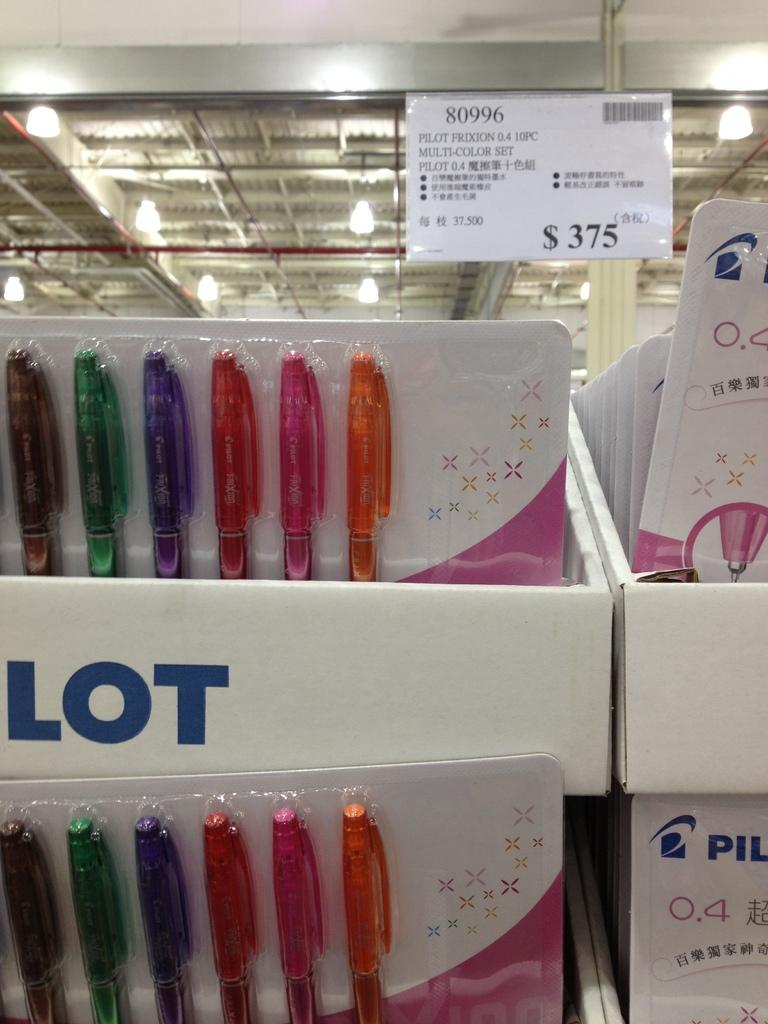How many pen packets are visible in the image? There are two pen packets in the image. What color are the boxes containing the pen packets? The pen packets are placed in white color boxes. What can be found on the boxes besides the pen packets? There is text on the boxes. What is visible at the top of the image? There are lights visible at the top of the image. How many fingers can be seen touching the pen packets in the image? There are no fingers visible in the image; it only shows the pen packets in white color boxes with text on them and lights visible at the top. 